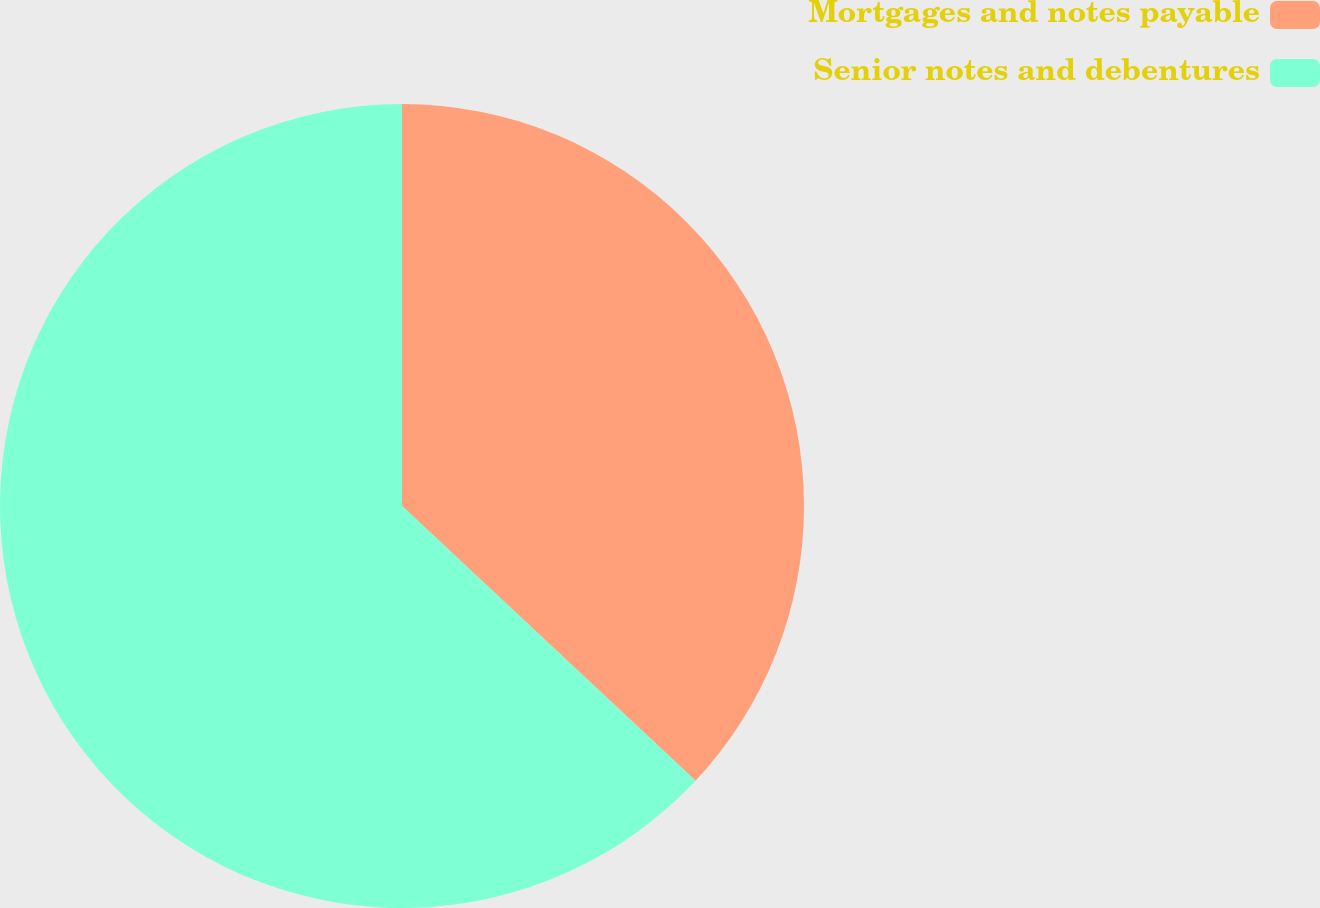Convert chart to OTSL. <chart><loc_0><loc_0><loc_500><loc_500><pie_chart><fcel>Mortgages and notes payable<fcel>Senior notes and debentures<nl><fcel>36.97%<fcel>63.03%<nl></chart> 